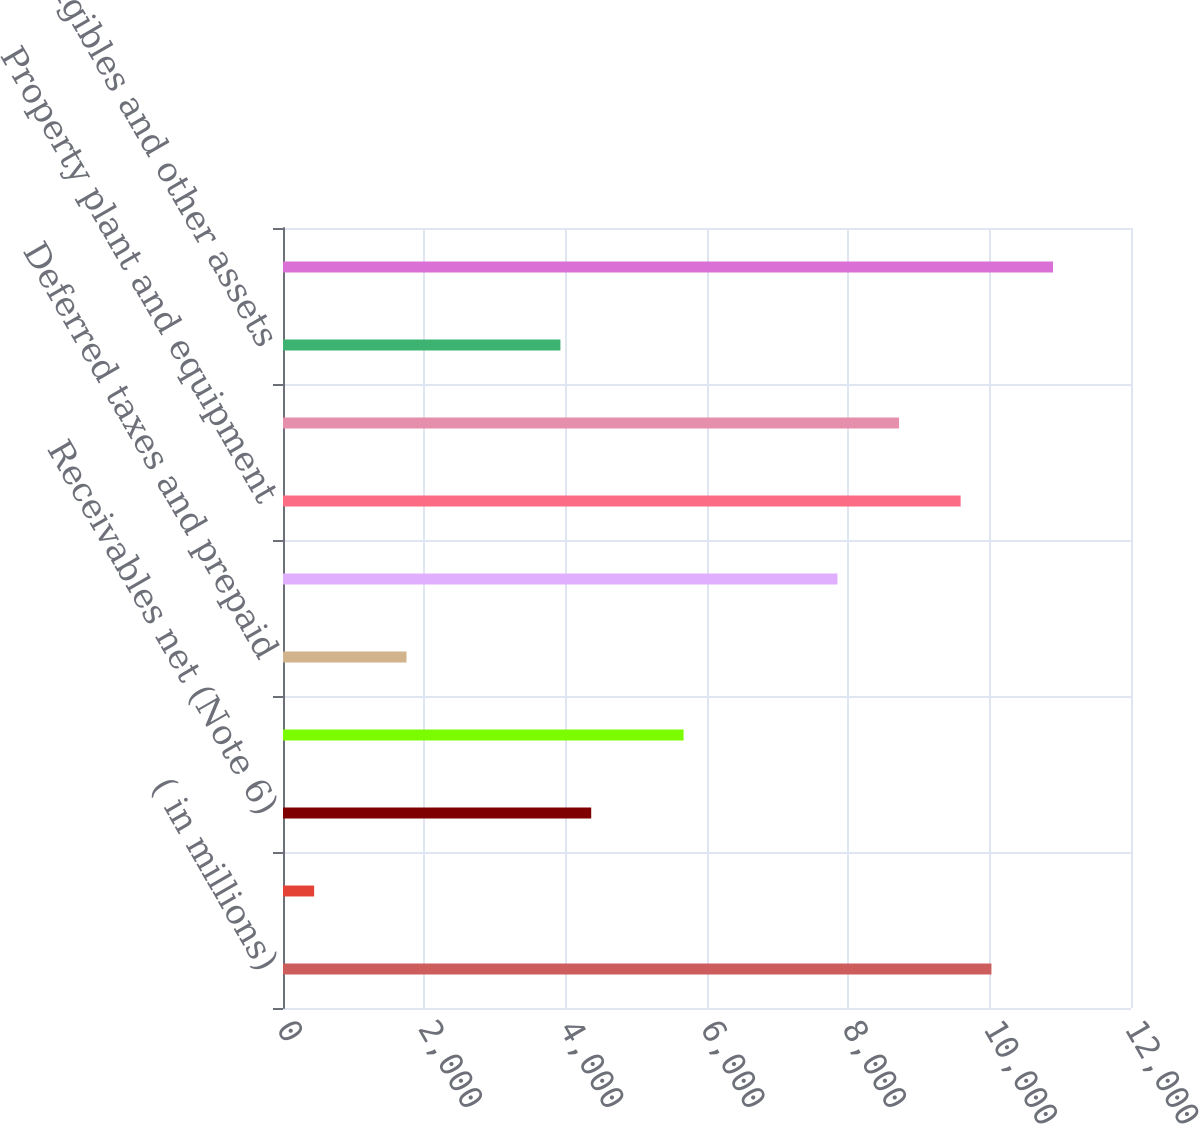<chart> <loc_0><loc_0><loc_500><loc_500><bar_chart><fcel>( in millions)<fcel>Cash and cash equivalents<fcel>Receivables net (Note 6)<fcel>Inventories net (Note 7) (a)<fcel>Deferred taxes and prepaid<fcel>Total current assets<fcel>Property plant and equipment<fcel>Goodwill (Notes 3 4 and 9)<fcel>Intangibles and other assets<fcel>Total Assets<nl><fcel>10024.8<fcel>440.74<fcel>4361.5<fcel>5668.42<fcel>1747.66<fcel>7846.62<fcel>9589.18<fcel>8717.9<fcel>3925.86<fcel>10896.1<nl></chart> 